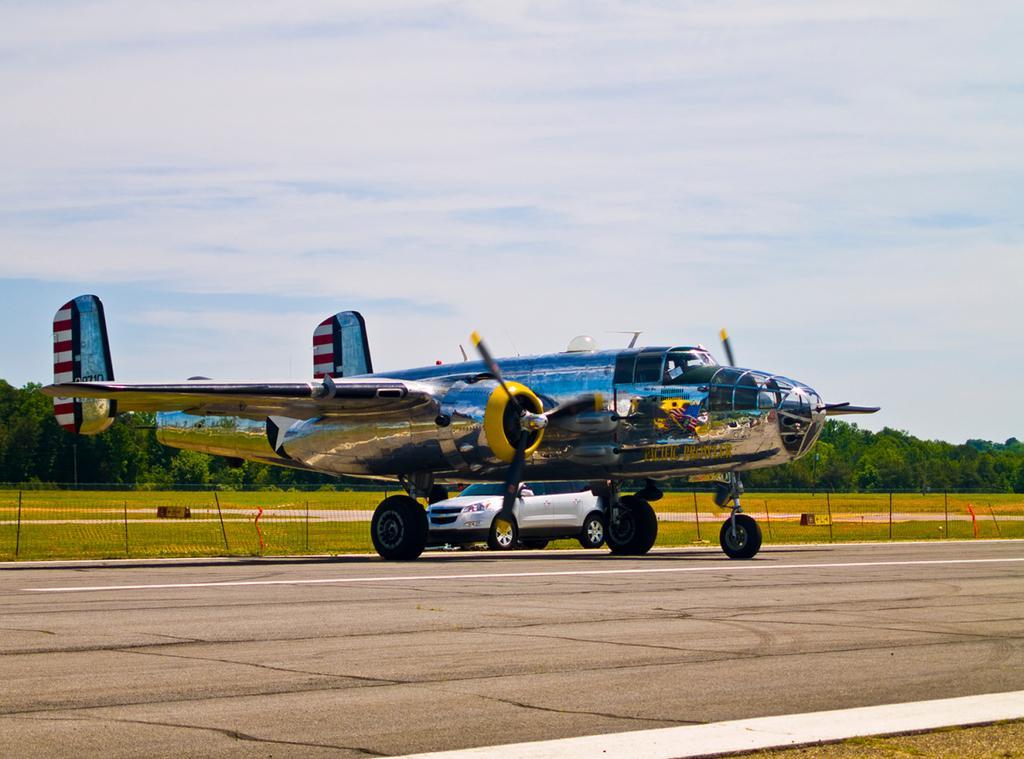Please provide a concise description of this image. In this image we can see an aircraft, and a car on the runway, there are trees, also we can see the sky and fencing. 